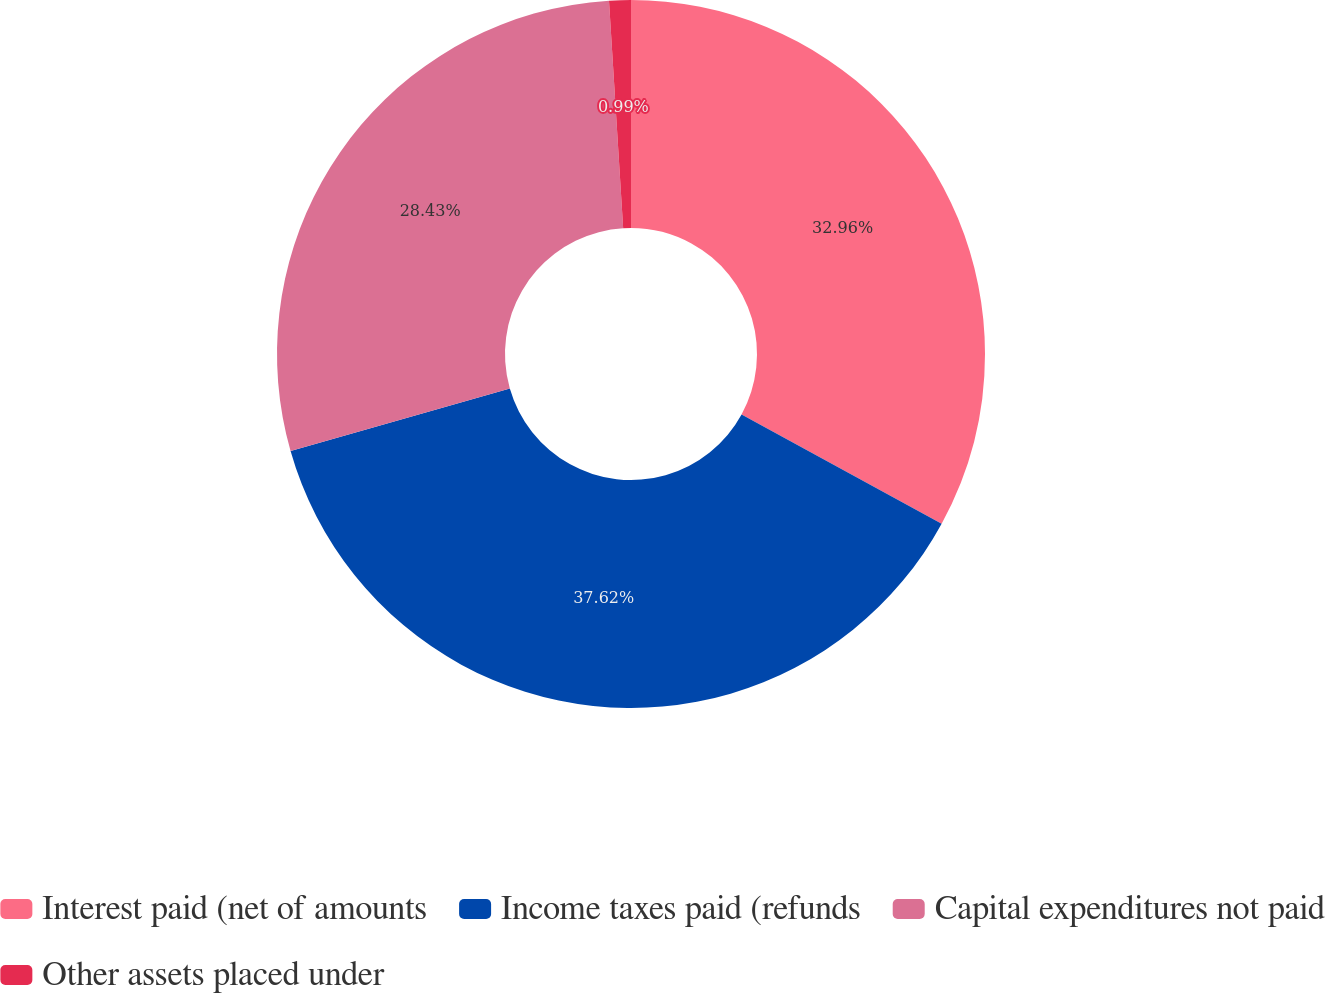Convert chart to OTSL. <chart><loc_0><loc_0><loc_500><loc_500><pie_chart><fcel>Interest paid (net of amounts<fcel>Income taxes paid (refunds<fcel>Capital expenditures not paid<fcel>Other assets placed under<nl><fcel>32.96%<fcel>37.62%<fcel>28.43%<fcel>0.99%<nl></chart> 